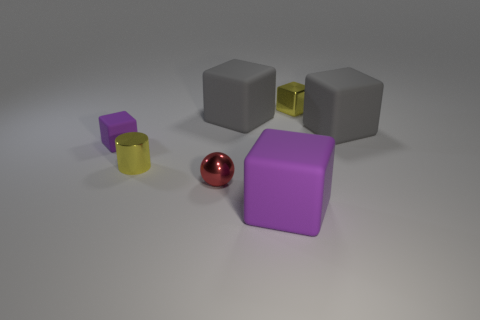Do the small metal cube and the metal cylinder have the same color?
Offer a very short reply. Yes. What number of other things are there of the same shape as the small purple rubber thing?
Ensure brevity in your answer.  4. Is the color of the tiny matte thing behind the tiny sphere the same as the matte object that is in front of the yellow cylinder?
Ensure brevity in your answer.  Yes. The cylinder that is the same size as the shiny ball is what color?
Give a very brief answer. Yellow. Is there a small metal block of the same color as the metal cylinder?
Offer a terse response. Yes. There is a shiny object that is on the right side of the red metal thing; is it the same size as the red shiny sphere?
Keep it short and to the point. Yes. Is the number of red spheres to the right of the small metal cube the same as the number of yellow balls?
Ensure brevity in your answer.  Yes. How many things are small yellow metallic things on the left side of the small sphere or yellow cylinders?
Ensure brevity in your answer.  1. There is a small object that is both on the right side of the tiny metal cylinder and behind the yellow cylinder; what is its shape?
Provide a succinct answer. Cube. What number of objects are gray objects that are to the right of the red metal ball or small yellow things behind the large purple matte block?
Your response must be concise. 4. 